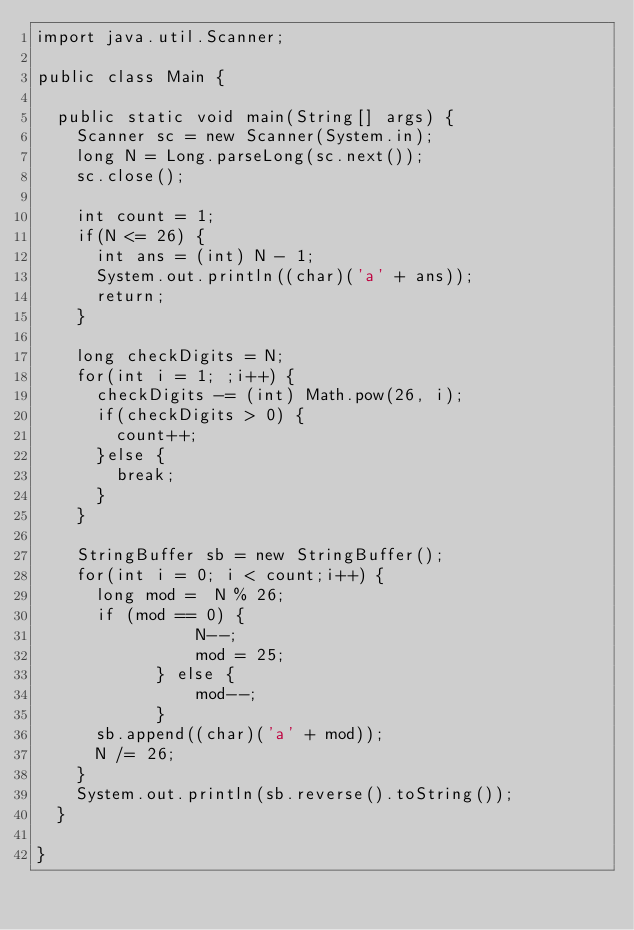<code> <loc_0><loc_0><loc_500><loc_500><_Java_>import java.util.Scanner;

public class Main {

	public static void main(String[] args) {
		Scanner sc = new Scanner(System.in);
		long N = Long.parseLong(sc.next());
		sc.close();

		int count = 1;
		if(N <= 26) {
			int ans = (int) N - 1;
			System.out.println((char)('a' + ans));
			return;
		}

		long checkDigits = N;
		for(int i = 1; ;i++) {
			checkDigits -= (int) Math.pow(26, i);
			if(checkDigits > 0) {
				count++;
			}else {
				break;
			}
		}

		StringBuffer sb = new StringBuffer();
		for(int i = 0; i < count;i++) {
			long mod =  N % 26;
			if (mod == 0) {
                N--;
                mod = 25;
            } else {
                mod--;
            }
			sb.append((char)('a' + mod));
			N /= 26;
		}
		System.out.println(sb.reverse().toString());
	}

}</code> 